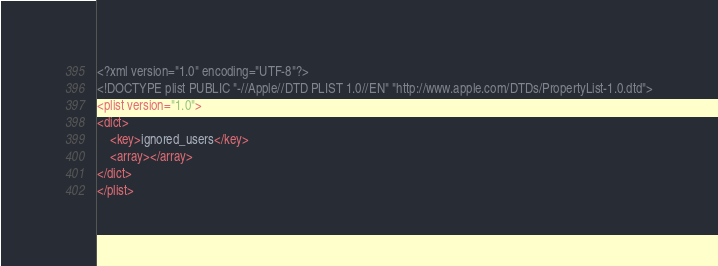<code> <loc_0><loc_0><loc_500><loc_500><_XML_><?xml version="1.0" encoding="UTF-8"?>
<!DOCTYPE plist PUBLIC "-//Apple//DTD PLIST 1.0//EN" "http://www.apple.com/DTDs/PropertyList-1.0.dtd">
<plist version="1.0">
<dict>
    <key>ignored_users</key>
    <array></array>
</dict>
</plist>
</code> 